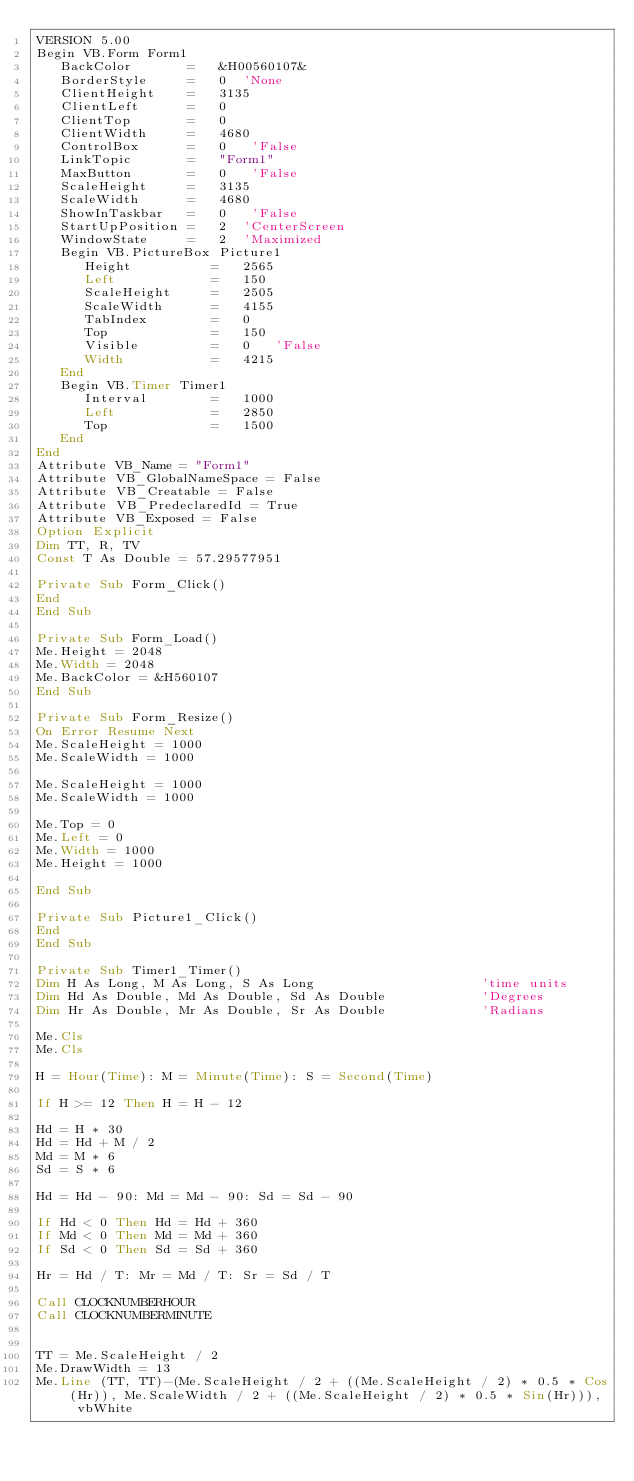Convert code to text. <code><loc_0><loc_0><loc_500><loc_500><_VisualBasic_>VERSION 5.00
Begin VB.Form Form1 
   BackColor       =   &H00560107&
   BorderStyle     =   0  'None
   ClientHeight    =   3135
   ClientLeft      =   0
   ClientTop       =   0
   ClientWidth     =   4680
   ControlBox      =   0   'False
   LinkTopic       =   "Form1"
   MaxButton       =   0   'False
   ScaleHeight     =   3135
   ScaleWidth      =   4680
   ShowInTaskbar   =   0   'False
   StartUpPosition =   2  'CenterScreen
   WindowState     =   2  'Maximized
   Begin VB.PictureBox Picture1 
      Height          =   2565
      Left            =   150
      ScaleHeight     =   2505
      ScaleWidth      =   4155
      TabIndex        =   0
      Top             =   150
      Visible         =   0   'False
      Width           =   4215
   End
   Begin VB.Timer Timer1 
      Interval        =   1000
      Left            =   2850
      Top             =   1500
   End
End
Attribute VB_Name = "Form1"
Attribute VB_GlobalNameSpace = False
Attribute VB_Creatable = False
Attribute VB_PredeclaredId = True
Attribute VB_Exposed = False
Option Explicit
Dim TT, R, TV
Const T As Double = 57.29577951

Private Sub Form_Click()
End
End Sub

Private Sub Form_Load()
Me.Height = 2048
Me.Width = 2048
Me.BackColor = &H560107
End Sub

Private Sub Form_Resize()
On Error Resume Next
Me.ScaleHeight = 1000
Me.ScaleWidth = 1000

Me.ScaleHeight = 1000
Me.ScaleWidth = 1000

Me.Top = 0
Me.Left = 0
Me.Width = 1000
Me.Height = 1000

End Sub

Private Sub Picture1_Click()
End
End Sub

Private Sub Timer1_Timer()
Dim H As Long, M As Long, S As Long                     'time units
Dim Hd As Double, Md As Double, Sd As Double            'Degrees
Dim Hr As Double, Mr As Double, Sr As Double            'Radians

Me.Cls
Me.Cls

H = Hour(Time): M = Minute(Time): S = Second(Time)

If H >= 12 Then H = H - 12

Hd = H * 30
Hd = Hd + M / 2
Md = M * 6
Sd = S * 6

Hd = Hd - 90: Md = Md - 90: Sd = Sd - 90

If Hd < 0 Then Hd = Hd + 360
If Md < 0 Then Md = Md + 360
If Sd < 0 Then Sd = Sd + 360

Hr = Hd / T: Mr = Md / T: Sr = Sd / T

Call CLOCKNUMBERHOUR
Call CLOCKNUMBERMINUTE


TT = Me.ScaleHeight / 2
Me.DrawWidth = 13
Me.Line (TT, TT)-(Me.ScaleHeight / 2 + ((Me.ScaleHeight / 2) * 0.5 * Cos(Hr)), Me.ScaleWidth / 2 + ((Me.ScaleHeight / 2) * 0.5 * Sin(Hr))), vbWhite</code> 